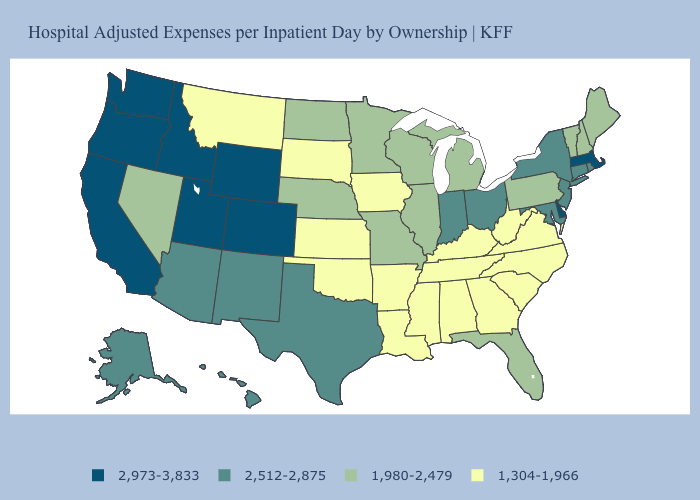What is the value of Hawaii?
Concise answer only. 2,512-2,875. Does Nebraska have a higher value than Hawaii?
Short answer required. No. Name the states that have a value in the range 1,304-1,966?
Give a very brief answer. Alabama, Arkansas, Georgia, Iowa, Kansas, Kentucky, Louisiana, Mississippi, Montana, North Carolina, Oklahoma, South Carolina, South Dakota, Tennessee, Virginia, West Virginia. What is the value of Delaware?
Answer briefly. 2,973-3,833. Name the states that have a value in the range 1,980-2,479?
Answer briefly. Florida, Illinois, Maine, Michigan, Minnesota, Missouri, Nebraska, Nevada, New Hampshire, North Dakota, Pennsylvania, Vermont, Wisconsin. Among the states that border Alabama , does Florida have the highest value?
Be succinct. Yes. Among the states that border Illinois , which have the lowest value?
Give a very brief answer. Iowa, Kentucky. Does Michigan have the highest value in the MidWest?
Quick response, please. No. What is the highest value in states that border Iowa?
Give a very brief answer. 1,980-2,479. What is the highest value in the USA?
Answer briefly. 2,973-3,833. Among the states that border Vermont , which have the lowest value?
Short answer required. New Hampshire. Does Massachusetts have the highest value in the USA?
Answer briefly. Yes. Name the states that have a value in the range 1,980-2,479?
Write a very short answer. Florida, Illinois, Maine, Michigan, Minnesota, Missouri, Nebraska, Nevada, New Hampshire, North Dakota, Pennsylvania, Vermont, Wisconsin. Among the states that border Florida , which have the lowest value?
Keep it brief. Alabama, Georgia. Name the states that have a value in the range 2,512-2,875?
Write a very short answer. Alaska, Arizona, Connecticut, Hawaii, Indiana, Maryland, New Jersey, New Mexico, New York, Ohio, Rhode Island, Texas. 